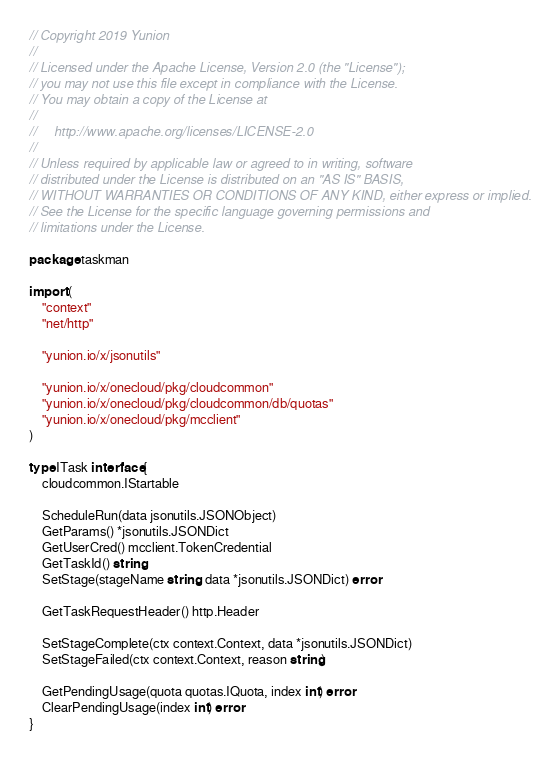<code> <loc_0><loc_0><loc_500><loc_500><_Go_>// Copyright 2019 Yunion
//
// Licensed under the Apache License, Version 2.0 (the "License");
// you may not use this file except in compliance with the License.
// You may obtain a copy of the License at
//
//     http://www.apache.org/licenses/LICENSE-2.0
//
// Unless required by applicable law or agreed to in writing, software
// distributed under the License is distributed on an "AS IS" BASIS,
// WITHOUT WARRANTIES OR CONDITIONS OF ANY KIND, either express or implied.
// See the License for the specific language governing permissions and
// limitations under the License.

package taskman

import (
	"context"
	"net/http"

	"yunion.io/x/jsonutils"

	"yunion.io/x/onecloud/pkg/cloudcommon"
	"yunion.io/x/onecloud/pkg/cloudcommon/db/quotas"
	"yunion.io/x/onecloud/pkg/mcclient"
)

type ITask interface {
	cloudcommon.IStartable

	ScheduleRun(data jsonutils.JSONObject)
	GetParams() *jsonutils.JSONDict
	GetUserCred() mcclient.TokenCredential
	GetTaskId() string
	SetStage(stageName string, data *jsonutils.JSONDict) error

	GetTaskRequestHeader() http.Header

	SetStageComplete(ctx context.Context, data *jsonutils.JSONDict)
	SetStageFailed(ctx context.Context, reason string)

	GetPendingUsage(quota quotas.IQuota, index int) error
	ClearPendingUsage(index int) error
}
</code> 